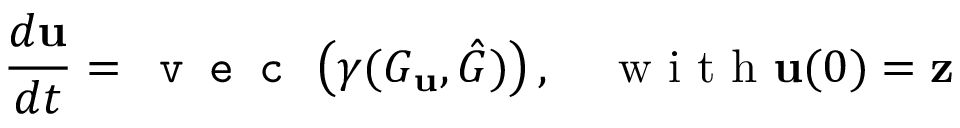<formula> <loc_0><loc_0><loc_500><loc_500>\frac { d u } { d t } = v e c \left ( \gamma ( G _ { u } , \hat { G } ) \right ) , \quad w i t h u ( 0 ) = z</formula> 